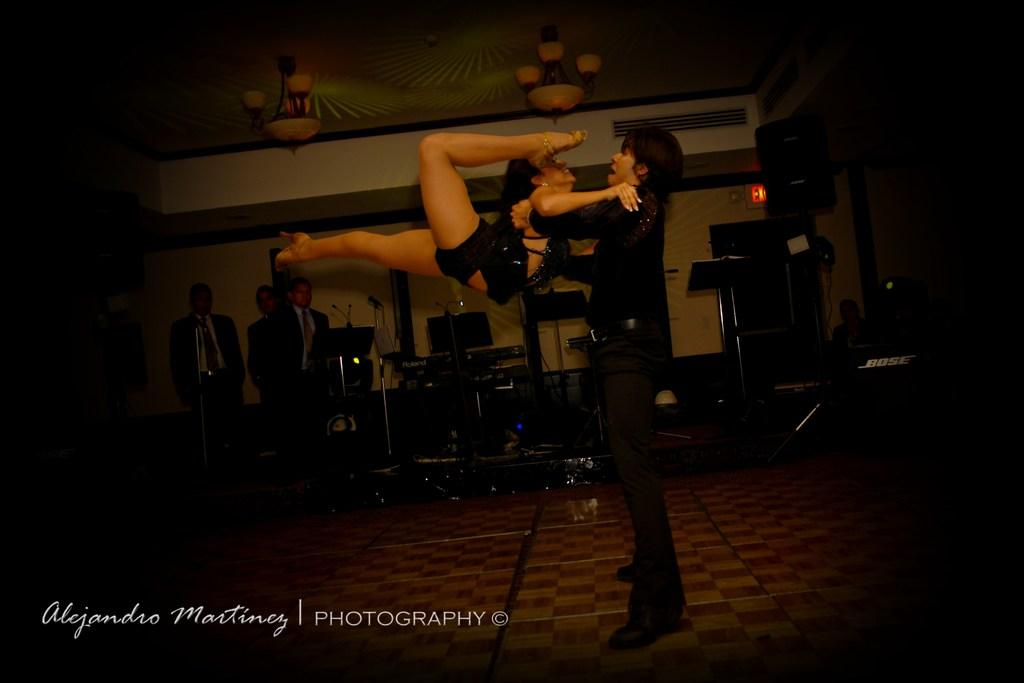Who is the main subject in the image? There is a man in the image. What is the man doing in the image? The man is lifting a woman. Can you describe the background of the image? There are people and music instruments visible in the background of the image. What is written at the bottom of the image? There is some text at the bottom of the image. Can you see any rifles in the image? No, there are no rifles present in the image. What type of twist is the woman performing in the image? The image does not depict a twist; the man is lifting the woman. 